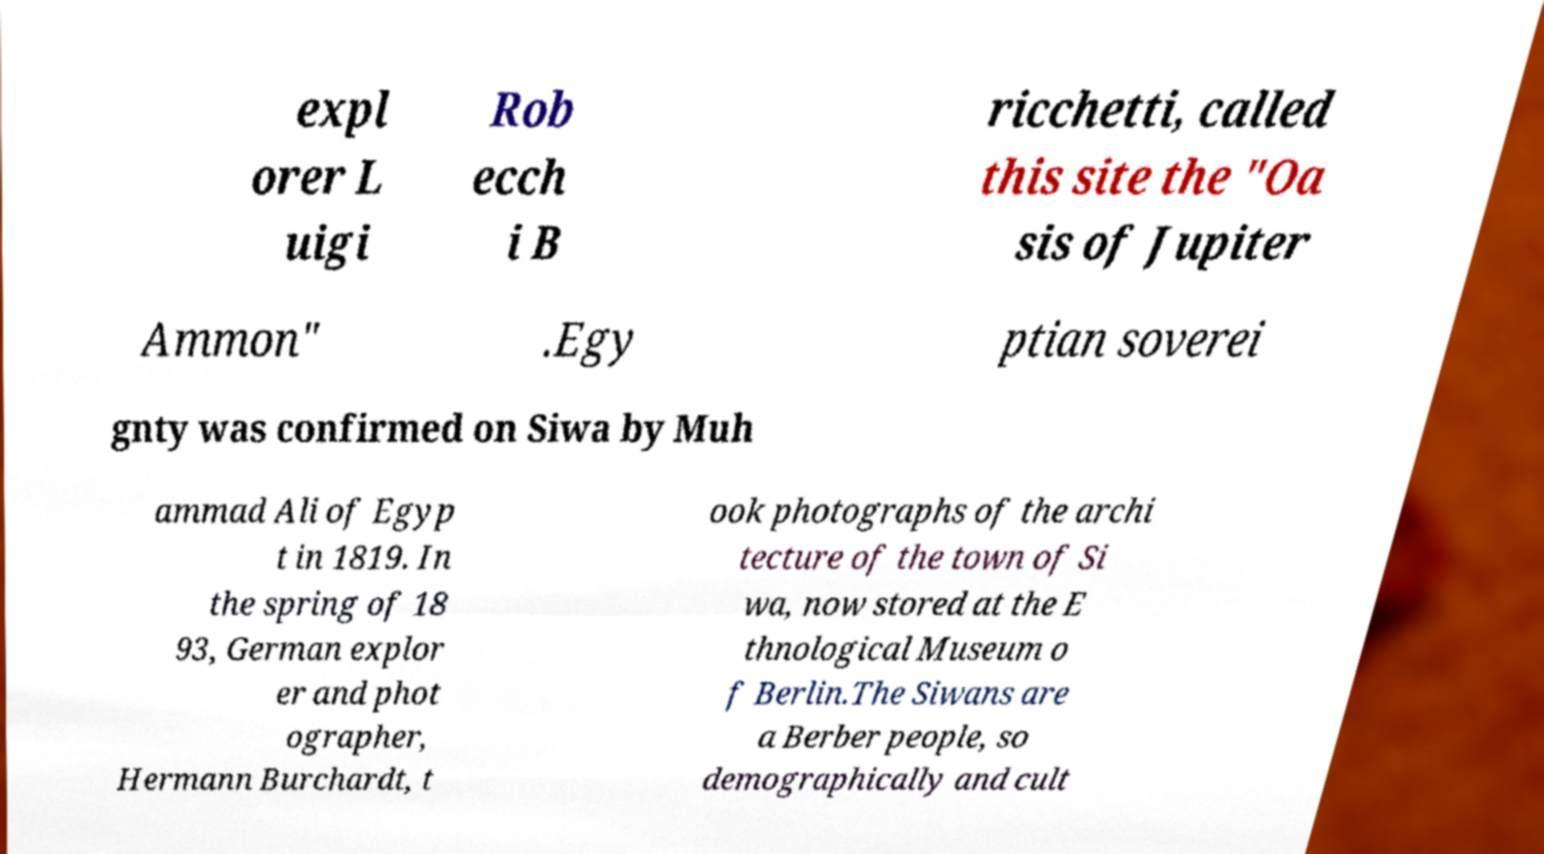Can you accurately transcribe the text from the provided image for me? expl orer L uigi Rob ecch i B ricchetti, called this site the "Oa sis of Jupiter Ammon" .Egy ptian soverei gnty was confirmed on Siwa by Muh ammad Ali of Egyp t in 1819. In the spring of 18 93, German explor er and phot ographer, Hermann Burchardt, t ook photographs of the archi tecture of the town of Si wa, now stored at the E thnological Museum o f Berlin.The Siwans are a Berber people, so demographically and cult 